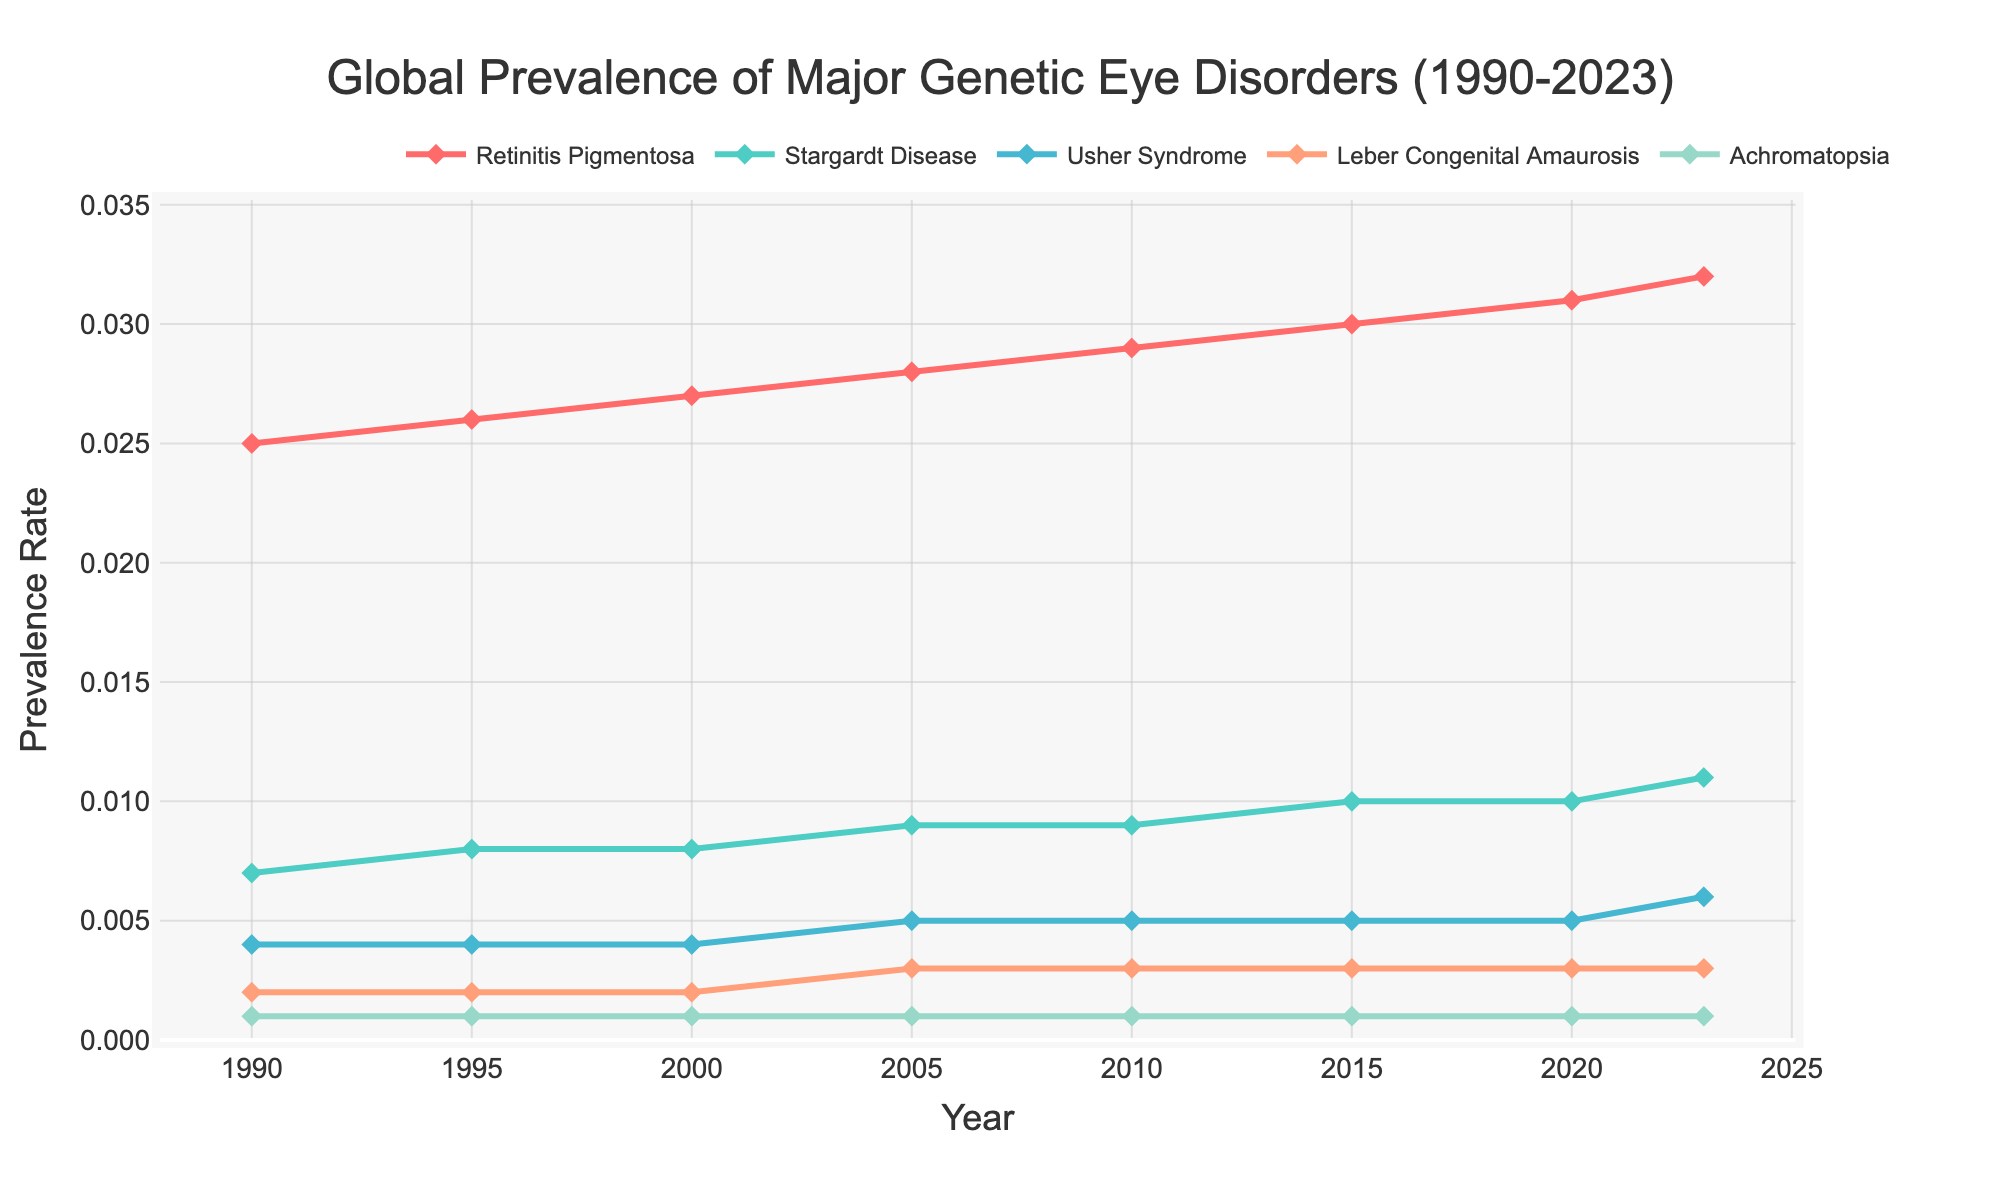What is the prevalence rate of Retinitis Pigmentosa in 1990? The figure has a line for Retinitis Pigmentosa, and you can look at the y-axis value for the year 1990, which is approximately 0.025.
Answer: 0.025 Which eye disorder shows the smallest increase in prevalence from 1990 to 2023? To determine this, compare the starting and ending values of each disorder’s prevalence in the lines represented. Leber Congenital Amaurosis and Achromatopsia both start and end at 0.002 and 0.001, respectively, showing no increase.
Answer: Leber Congenital Amaurosis and Achromatopsia What's the difference in prevalence rate between Stargardt Disease and Usher Syndrome in 2023? Look at the y-axis values for Stargardt Disease (0.011) and Usher Syndrome (0.006) in 2023 and then subtract the smaller value from the larger one.
Answer: 0.005 By how much did the prevalence rate for Retinitis Pigmentosa increase from 2000 to 2020? Subtract the prevalence rate in 2000 (0.027) from the prevalence rate in 2020 (0.031).
Answer: 0.004 Which disorder had the highest prevalence rate in 2010? In the year 2010, by comparing the y-axis values of all the disorders, Retinitis Pigmentosa has the highest value which is approximately 0.029.
Answer: Retinitis Pigmentosa What is the combined prevalence rate for Leber Congenital Amaurosis and Achromatopsia in 2005? Add the prevalence rates of Leber Congenital Amaurosis (0.003) and Achromatopsia (0.001) from the year 2005.
Answer: 0.004 Is the trend of Stargardt Disease prevalence from 1990 to 2023 increasing, decreasing, or stable? Observe the line representing Stargardt Disease; it starts at 0.007 in 1990 and ends at 0.011 in 2023. The line shows an upward trend.
Answer: Increasing How does the prevalence rate of Usher Syndrome in 2015 compare to its rate in 2005? Compare the y-axis values of Usher Syndrome; in 2005, it is 0.005, and in 2015 it is also 0.005, indicating no change.
Answer: No change What’s the average prevalence rate of Achromatopsia over the entire period? Sum up the prevalence rates of Achromatopsia for all the years (0.001+0.001+0.001+0.001+0.001+0.001+0.001+0.001 = 0.008) and divide by the number of years (8).
Answer: 0.001 